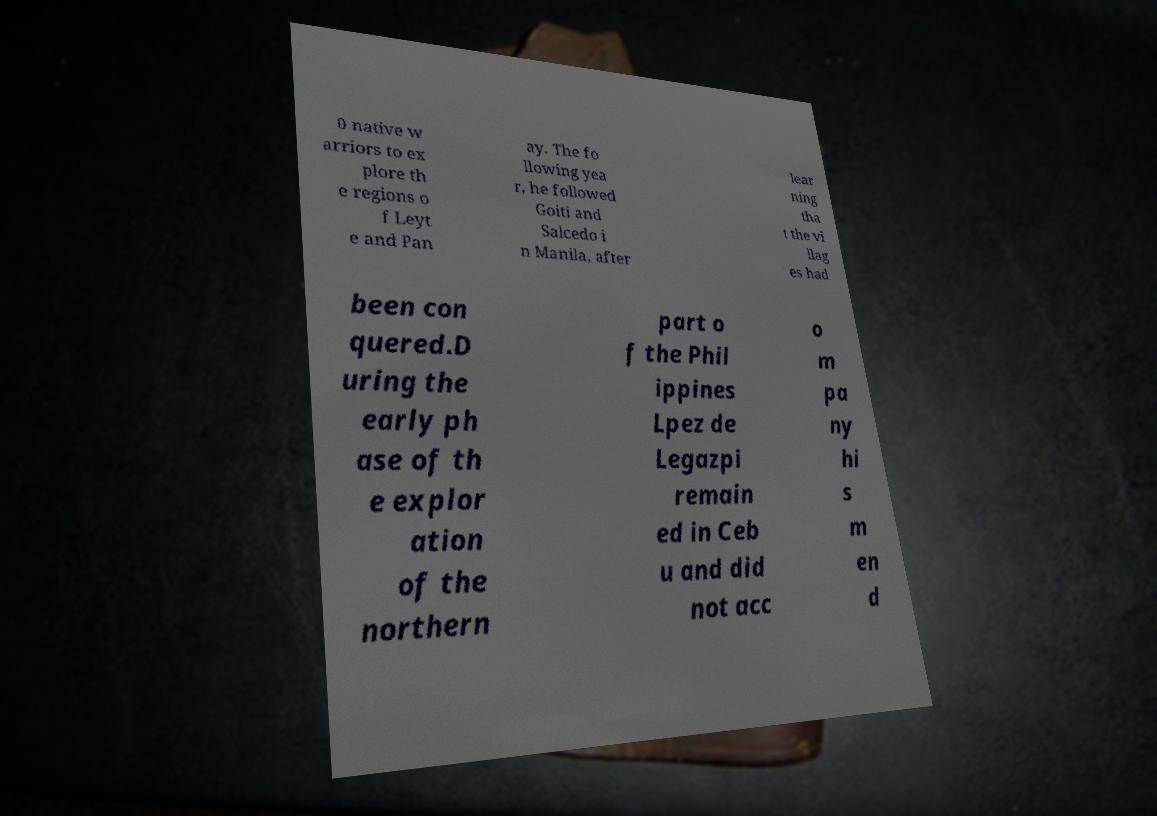Please read and relay the text visible in this image. What does it say? 0 native w arriors to ex plore th e regions o f Leyt e and Pan ay. The fo llowing yea r, he followed Goiti and Salcedo i n Manila, after lear ning tha t the vi llag es had been con quered.D uring the early ph ase of th e explor ation of the northern part o f the Phil ippines Lpez de Legazpi remain ed in Ceb u and did not acc o m pa ny hi s m en d 